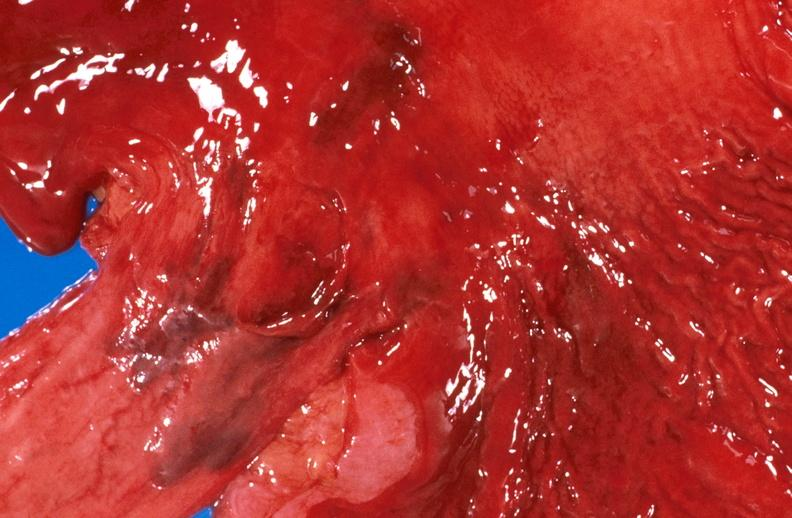does this image show esophageal varices due to alcoholic cirrhosis?
Answer the question using a single word or phrase. Yes 